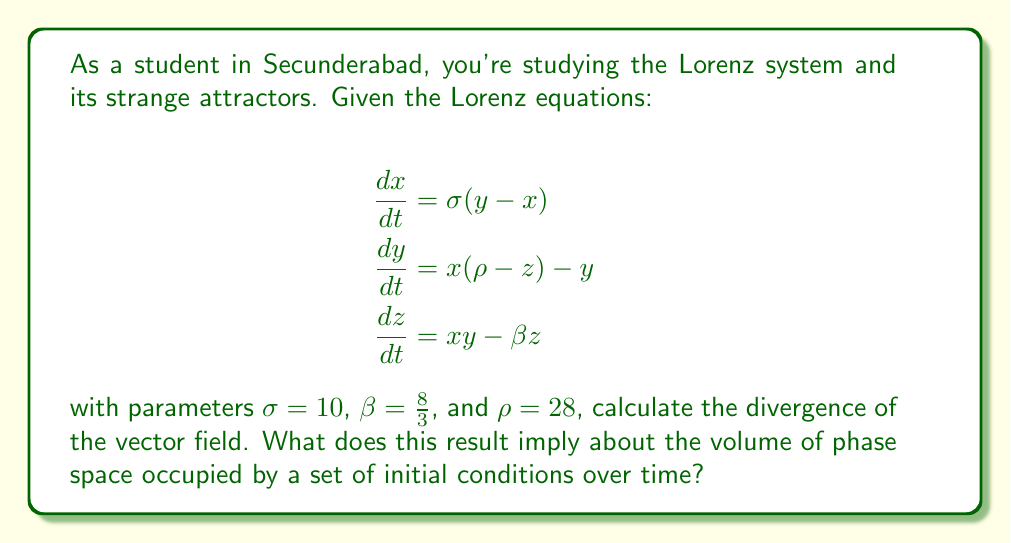What is the answer to this math problem? Let's approach this step-by-step:

1) The divergence of a vector field $\mathbf{F}(x, y, z) = (F_1, F_2, F_3)$ is given by:

   $$\nabla \cdot \mathbf{F} = \frac{\partial F_1}{\partial x} + \frac{\partial F_2}{\partial y} + \frac{\partial F_3}{\partial z}$$

2) In our case, $F_1 = \sigma(y - x)$, $F_2 = x(\rho - z) - y$, and $F_3 = xy - \beta z$

3) Let's calculate each partial derivative:

   $$\frac{\partial F_1}{\partial x} = -\sigma$$
   $$\frac{\partial F_2}{\partial y} = -1$$
   $$\frac{\partial F_3}{\partial z} = -\beta$$

4) Now, we can sum these to get the divergence:

   $$\nabla \cdot \mathbf{F} = -\sigma - 1 - \beta = -(\sigma + 1 + \beta)$$

5) Substituting the given values:

   $$\nabla \cdot \mathbf{F} = -(10 + 1 + \frac{8}{3}) = -(\frac{41}{3})$$

6) The divergence is negative, which implies that the volume of phase space occupied by a set of initial conditions will contract over time. This is a key characteristic of strange attractors in dissipative systems like the Lorenz system.

7) Specifically, the rate of contraction of a volume $V$ in phase space is given by:

   $$\frac{d}{dt}\ln V(t) = \nabla \cdot \mathbf{F}$$

8) Since this is negative, the volume will decrease exponentially over time, eventually collapsing onto a lower-dimensional attractor - in this case, the famous Lorenz strange attractor.
Answer: $-\frac{41}{3}$; Volume in phase space contracts exponentially. 